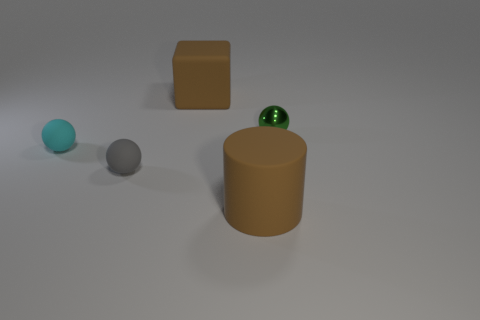Subtract 1 spheres. How many spheres are left? 2 Add 1 big brown things. How many objects exist? 6 Subtract all cylinders. How many objects are left? 4 Add 3 small gray objects. How many small gray objects are left? 4 Add 5 large cyan metal balls. How many large cyan metal balls exist? 5 Subtract 1 brown blocks. How many objects are left? 4 Subtract all green metal cylinders. Subtract all tiny gray things. How many objects are left? 4 